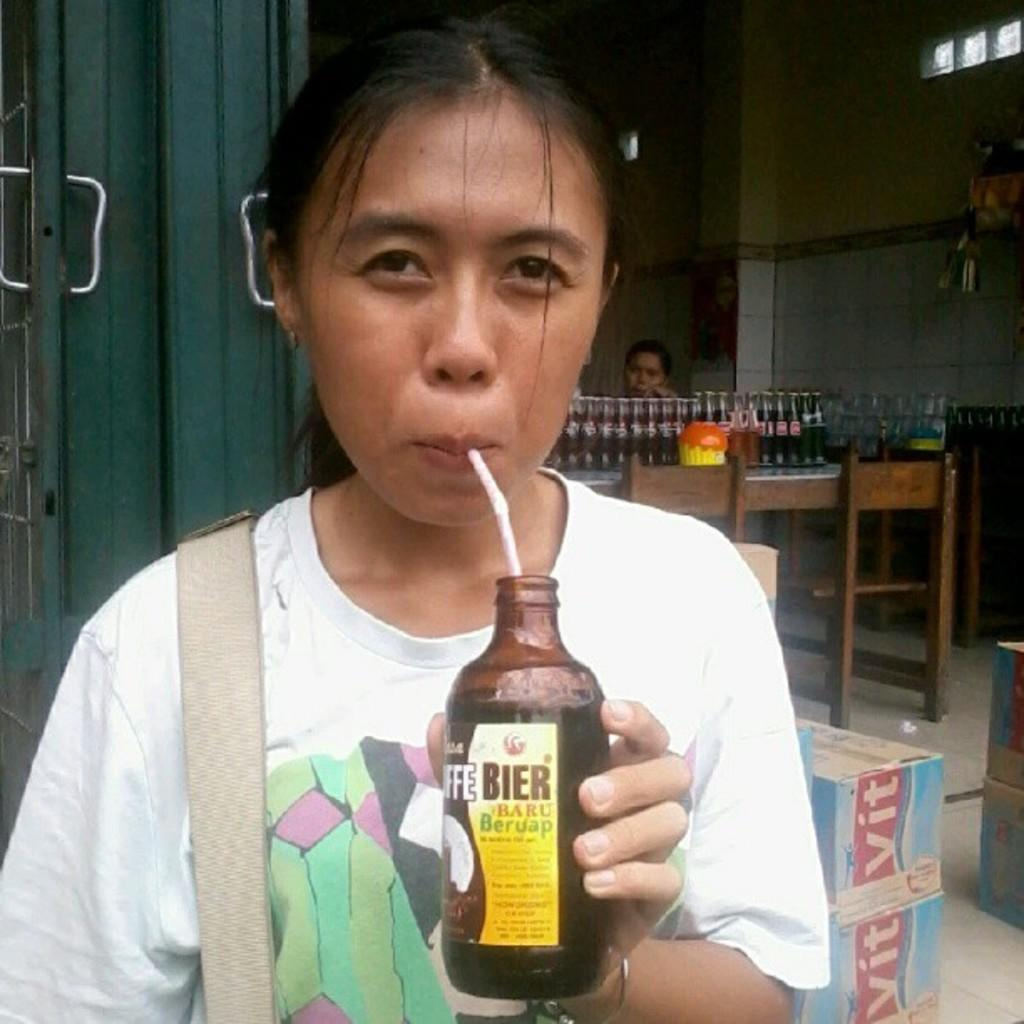Who is the main subject in the image? There is a lady in the image. What is the lady doing in the image? The lady is drinking a liquid. What is the name of the liquid she is drinking? The liquid is named "biar baru". What can be seen in the background of the image? There are bottles on a table in the background of the image. Where was the image taken? The image was taken inside a restaurant. What advice is the lady giving to the book in the image? There is no book present in the image, and the lady is not giving any advice. 